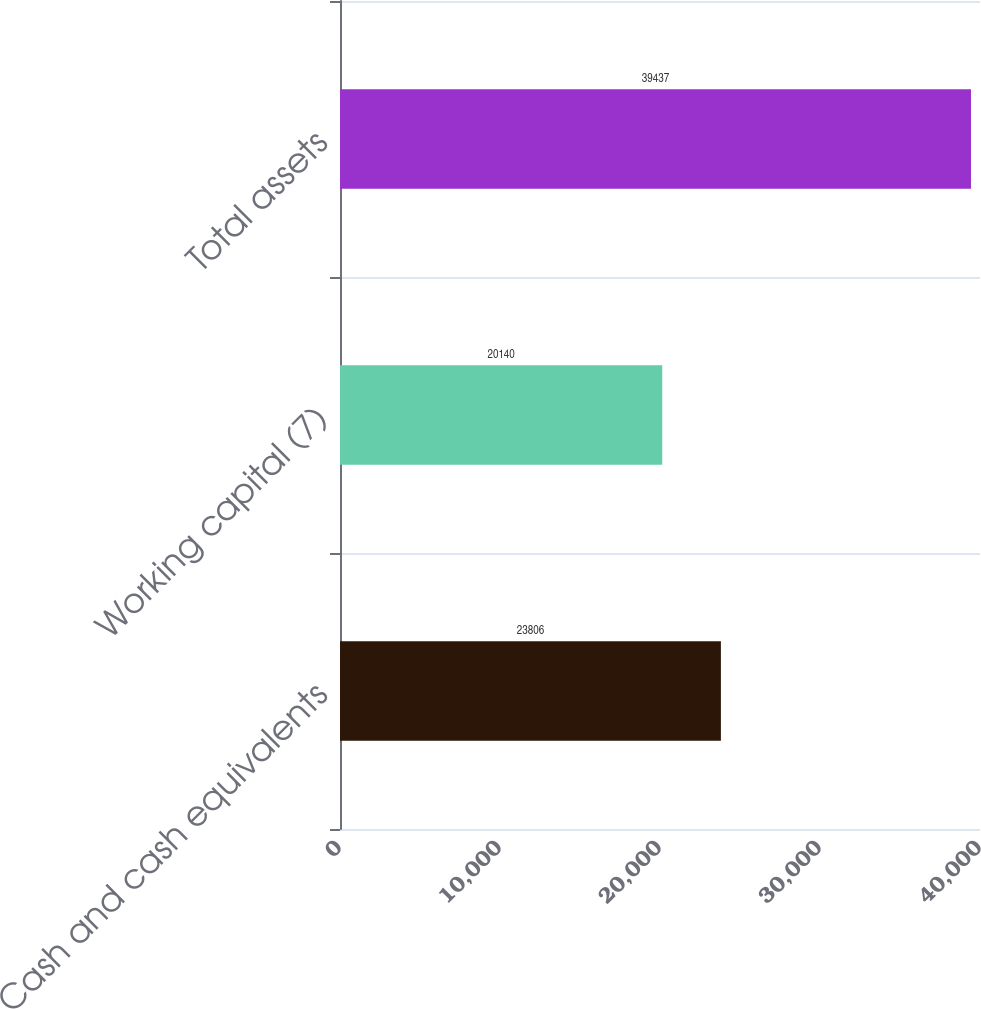Convert chart to OTSL. <chart><loc_0><loc_0><loc_500><loc_500><bar_chart><fcel>Cash and cash equivalents<fcel>Working capital (7)<fcel>Total assets<nl><fcel>23806<fcel>20140<fcel>39437<nl></chart> 